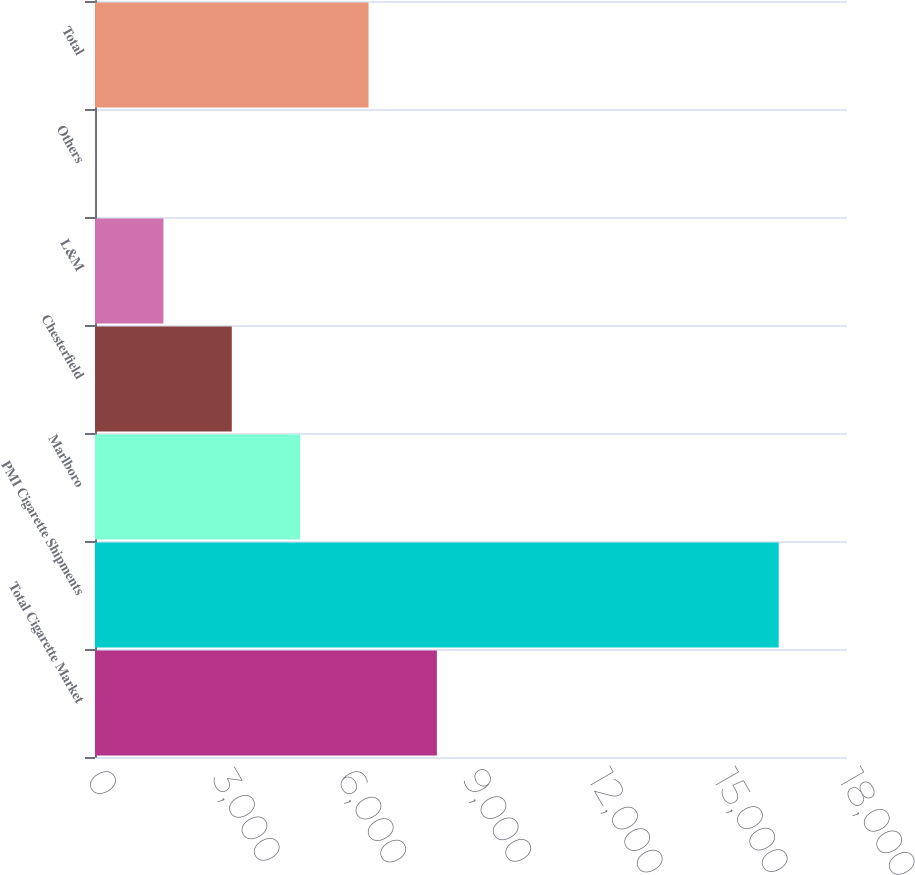<chart> <loc_0><loc_0><loc_500><loc_500><bar_chart><fcel>Total Cigarette Market<fcel>PMI Cigarette Shipments<fcel>Marlboro<fcel>Chesterfield<fcel>L&M<fcel>Others<fcel>Total<nl><fcel>8183.45<fcel>16365<fcel>4910.83<fcel>3274.52<fcel>1638.21<fcel>1.9<fcel>6547.14<nl></chart> 